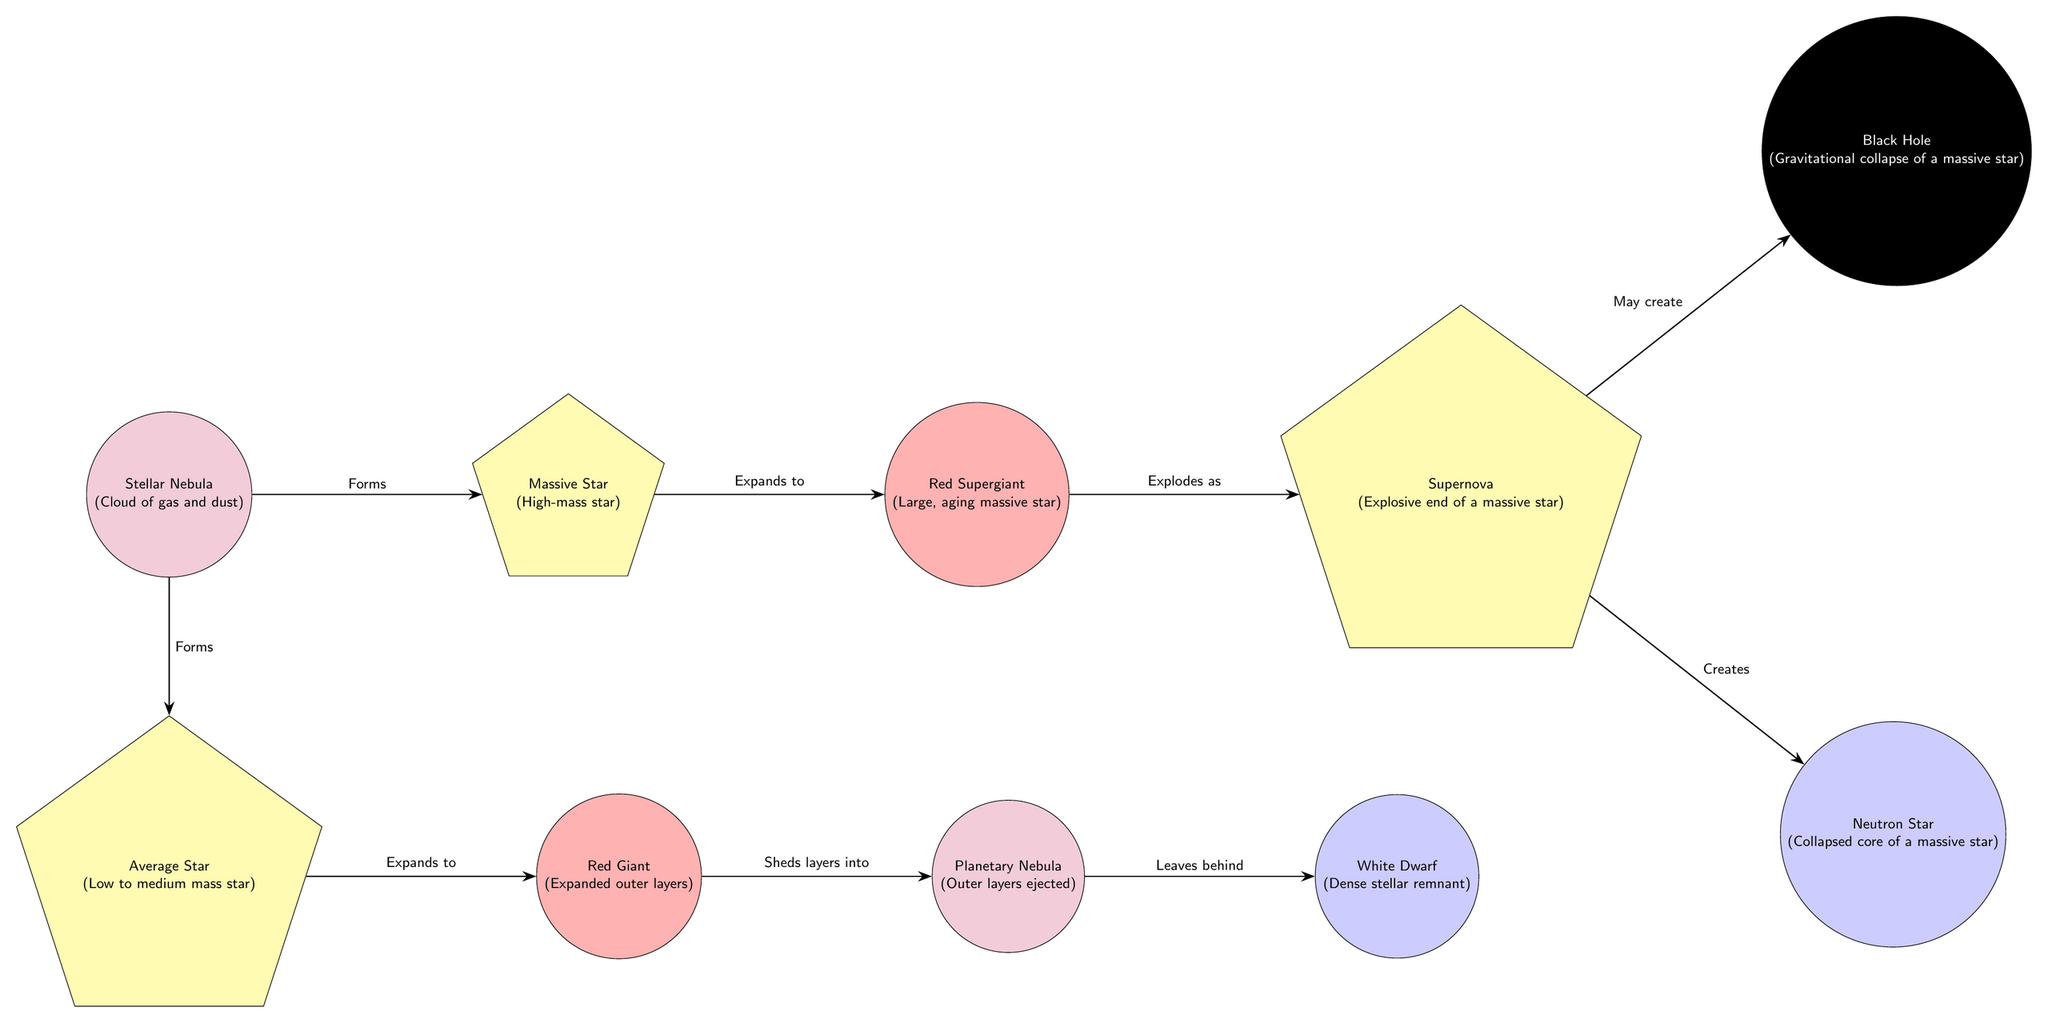What is the first stage in the lifecycle of a star? According to the diagram, the first stage is the Stellar Nebula, as it is the starting point from which other stages develop.
Answer: Stellar Nebula How many different end states are there for massive stars indicated in the diagram? The diagram shows two possible end states for massive stars: a Neutron Star and a Black Hole, based on the outcome of a supernova.
Answer: 2 What do red giants shed into the surrounding space? The diagram specifies that red giants shed their outer layers, which become the planetary nebula in the subsequent stage.
Answer: Layers What forms from the expansion of an average star? The diagram shows that an average star expands to become a Red Giant, indicating that this is the result of the expansion.
Answer: Red Giant What happens to a massive star at the end of its life cycle? The representation in the diagram indicates that a massive star ends its life cycle by exploding as a Supernova, which then leads to other possible outcomes.
Answer: Supernova What is the relationship between a supernova and neutron stars? The diagram illustrates that a supernova creates a Neutron Star, establishing a direct connection between the explosion and the formation of the neutron star.
Answer: Creates How do white dwarfs form according to the diagram? The diagram links the formation of a White Dwarf as a remnant left behind after the outer layers of an average star are shed into a planetary nebula.
Answer: Leaves behind Which node is directly related to both exploding supernova and black holes? The diagram shows that a supernova has a relationship with both a Neutron Star and a Black Hole, indicating these are direct outcomes from the explosion of a massive star.
Answer: Supernova What color represents the dense stellar remnants in the diagram? The diagram uses blue to represent a White Dwarf, indicating that this is the color associated with dense stellar remnants.
Answer: Blue 